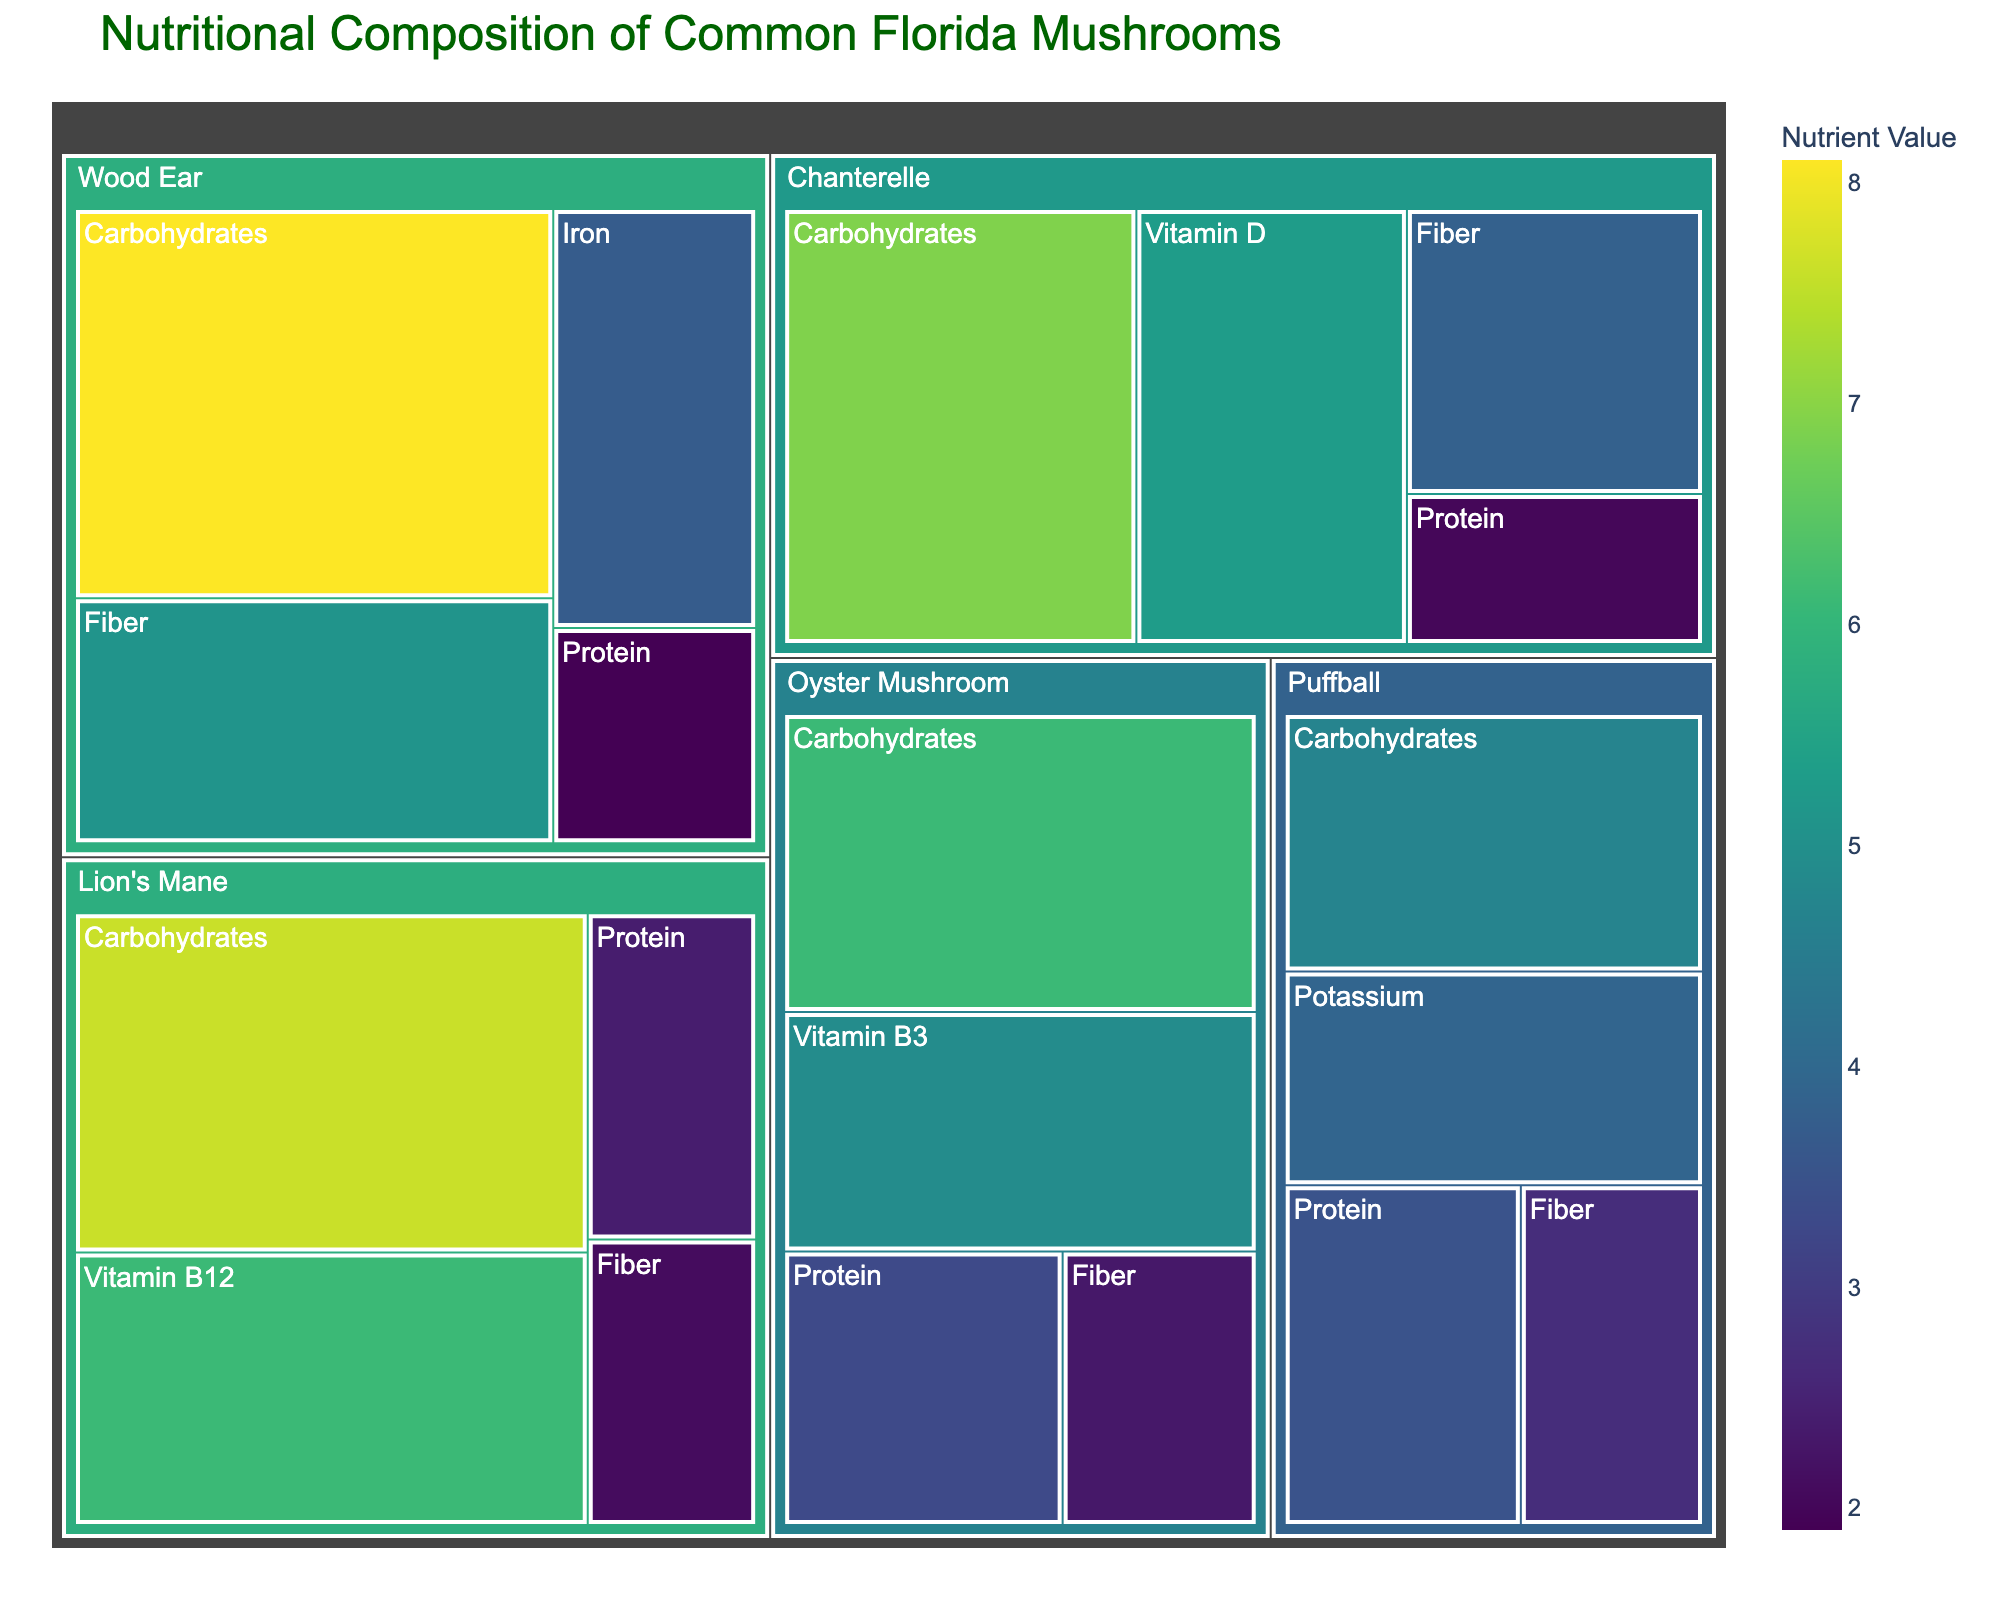What is the title of the treemap figure? The title is displayed at the top of the treemap and usually provides information about what the figure is representing. In this case, the title directly explains the content of the treemap.
Answer: Nutritional Composition of Common Florida Mushrooms Which mushroom has the highest carbohydrate value? To find the mushroom with the highest carbohydrate value, look for the largest rectangle labeled "Carbohydrates" and find which mushroom it is nested under.
Answer: Wood Ear How much protein is in Lion's Mane mushrooms? Locate the Lion's Mane section within the treemap, then find the subsection labeled "Protein" and note its value.
Answer: 2.4 Which nutrient is the most abundant in Wood Ear mushrooms? Within the section labeled "Wood Ear", identify the largest sub-rectangle to determine the most abundant nutrient.
Answer: Carbohydrates What is the total fiber content of all the mushrooms combined? Identify the value of fiber for each mushroom, then sum these values: 3.8 (Chanterelle) + 2.3 (Oyster Mushroom) + 2.7 (Puffball) + 2.1 (Lion's Mane) + 5.1 (Wood Ear).
Answer: 16.0 Compare the protein content between Puffball and Oyster Mushroom. Which one is higher? Locate the "Protein" subsections under both Puffball and Oyster Mushroom and compare their values.
Answer: Oyster Mushroom Which mushroom contains Vitamin B12? Look through the different sections of the treemap to find which mushroom has a subsection labeled "Vitamin B12".
Answer: Lion's Mane If you combine the carbohydrate values of Chanterelle and Lion's Mane, what is the total? Find the carbohydrate value for both Chanterelle and Lion's Mane, then add them together: 6.9 (Chanterelle) + 7.6 (Lion's Mane).
Answer: 14.5 What is the nutrient with the lowest recorded value and which mushroom does it belong to? Identify the smallest numeric value in the treemap and note the corresponding nutrient and mushroom.
Answer: Protein, Wood Ear 